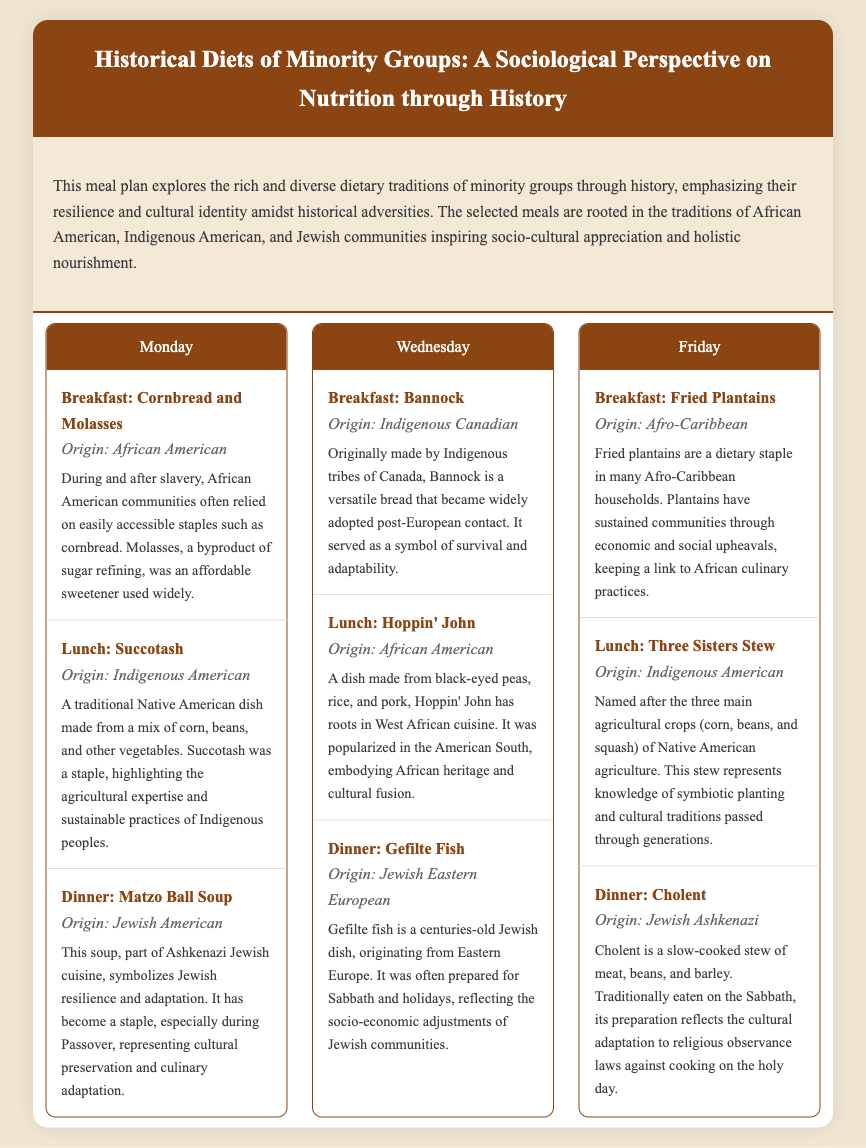What is the title of the document? The title is provided in the header of the document, specifically stating the focus on historical diets from a sociological perspective.
Answer: Historical Diets of Minority Groups: A Sociological Perspective on Nutrition through History What is the origin of Cornbread and Molasses? The document lists the meal origin for Cornbread and Molasses under the breakfast section for Monday.
Answer: African American Which minority group's dietary tradition includes Matzo Ball Soup? The meal plan indicates which group is represented by each dish, highlighting cultural significance.
Answer: Jewish American How many meals are mentioned for each day in the meal plan? Each day in the meal plan consistently includes three meals, contributing to the structure and organization.
Answer: Three What is the context provided for Hoppin' John? Understanding the context requires looking at the description given in the document which explains the cultural background of the meal.
Answer: A dish made from black-eyed peas, rice, and pork, Hoppin' John has roots in West African cuisine On which day is Fried Plantains served? The question seeks to check the schedule provided in the meal plan, identifying the specific day for the dish.
Answer: Friday What agricultural knowledge does the Three Sisters Stew represent? The context provides insight into the traditional agricultural practices connected to the dish, enhancing cultural understanding.
Answer: Knowledge of symbiotic planting Which dish is traditionally eaten on the Sabbath? The document specifies certain meals linked to cultural or religious practices, indicating their significance.
Answer: Cholent 